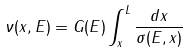<formula> <loc_0><loc_0><loc_500><loc_500>\nu ( x , E ) = G ( E ) \int _ { x } ^ { L } \frac { d x } { \sigma ( E , x ) }</formula> 